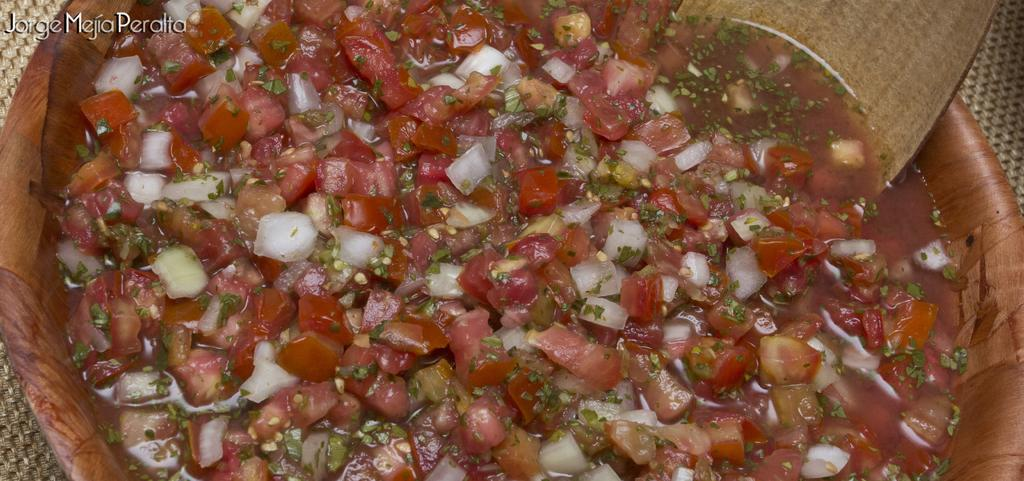What is the main subject of the image? The image is a zoomed in picture of a food item. What utensil can be seen in the bowl? There is a wooden spoon in the bowl. Where is the bowl placed? The bowl is on a mat. What is present in the top left corner of the image? There is text in the top left corner of the image. What type of record can be seen spinning on the mat in the image? There is no record present in the image; it is a picture of a food item with a wooden spoon in a bowl on a mat. What type of holiday is being celebrated in the image? There is no indication of a holiday being celebrated in the image. 